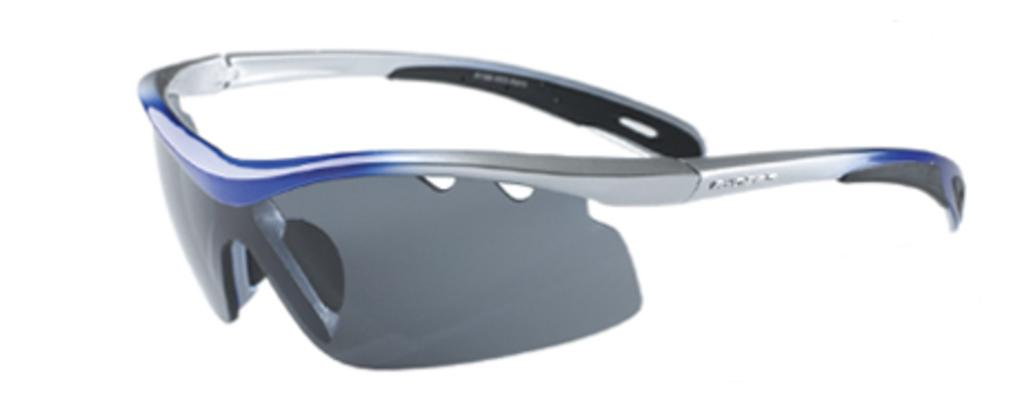What type of accessory is present in the image? There are goggles in the image. What color is the background of the image? The background of the image is white. How many geese are present in the image? There are no geese present in the image; it only features goggles against a white background. 